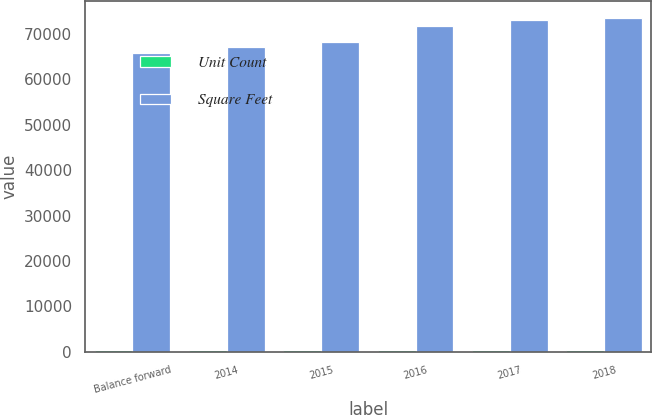<chart> <loc_0><loc_0><loc_500><loc_500><stacked_bar_chart><ecel><fcel>Balance forward<fcel>2014<fcel>2015<fcel>2016<fcel>2017<fcel>2018<nl><fcel>Unit Count<fcel>393<fcel>405<fcel>411<fcel>432<fcel>439<fcel>443<nl><fcel>Square Feet<fcel>65801<fcel>67205<fcel>68269<fcel>71724<fcel>73172<fcel>73615<nl></chart> 